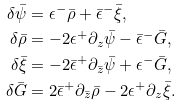<formula> <loc_0><loc_0><loc_500><loc_500>\delta \bar { \psi } & = \epsilon ^ { - } \bar { \rho } + \bar { \epsilon } ^ { - } \bar { \xi } , \\ \delta \bar { \rho } & = - 2 \epsilon ^ { + } \partial _ { z } \bar { \psi } - \bar { \epsilon } ^ { - } \bar { G } , \\ \delta \bar { \xi } & = - 2 \bar { \epsilon } ^ { + } \partial _ { \bar { z } } \bar { \psi } + \epsilon ^ { - } \bar { G } , \\ \delta \bar { G } & = 2 \bar { \epsilon } ^ { + } \partial _ { \bar { z } } \bar { \rho } - 2 \epsilon ^ { + } \partial _ { z } \bar { \xi } .</formula> 